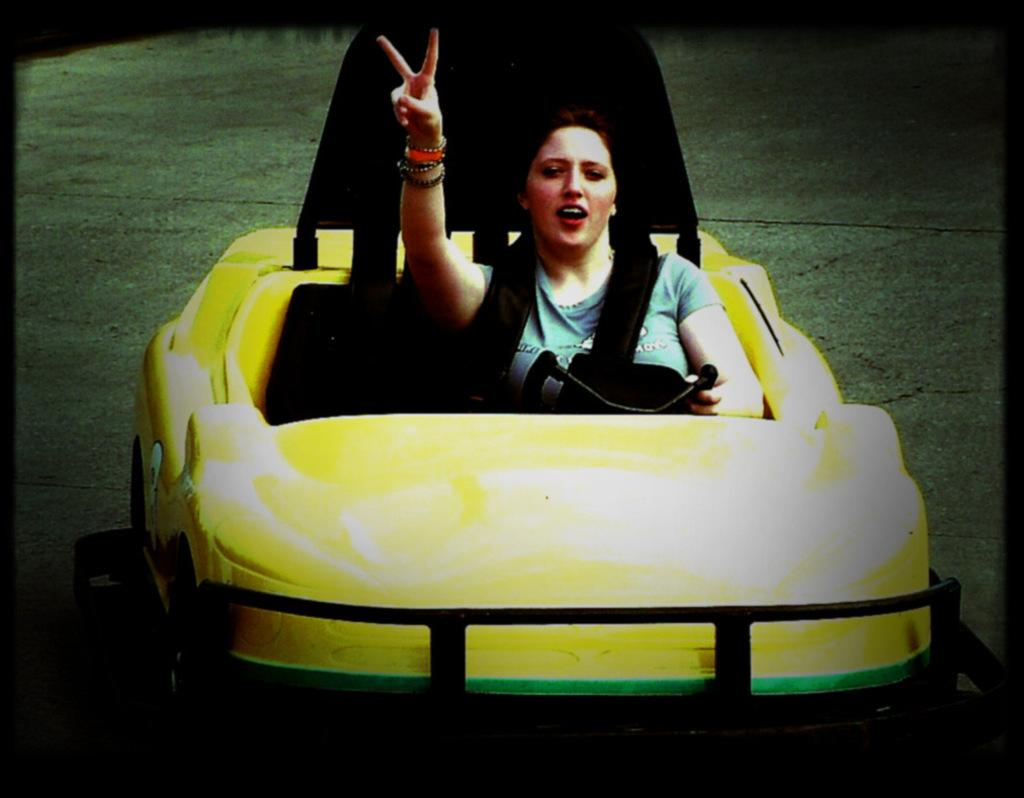Who is present in the image? There is a woman in the image. What is the woman doing in the image? The woman is sitting in a car. What type of furniture is the woman using to sleep in the image? There is no furniture or indication of sleeping in the image; the woman is sitting in a car. What tool is the woman using to tighten bolts in the image? There is no tool or indication of working with bolts in the image; the woman is sitting in a car. 